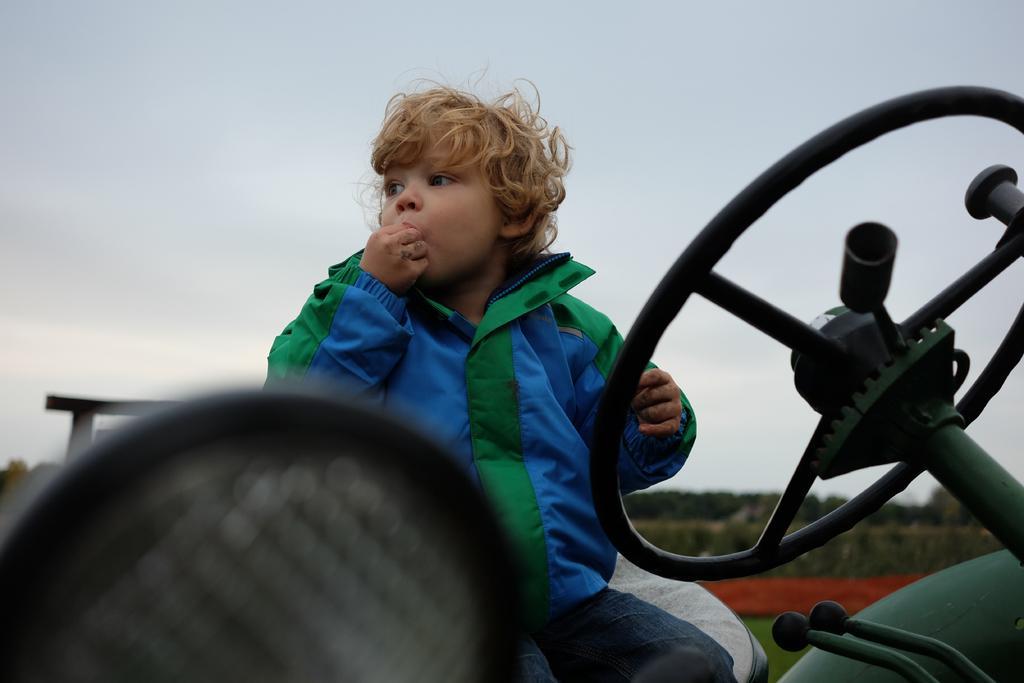Please provide a concise description of this image. This is completely an outdoor picture. On the background of the picture we can see a sky. These are the trees. This picture is mainly highlighted with a boy , sitting in the vehicle and eating something with his hand. This boy is wearing a jacket which is blue and green in color. This is the steering of the vehicle. 